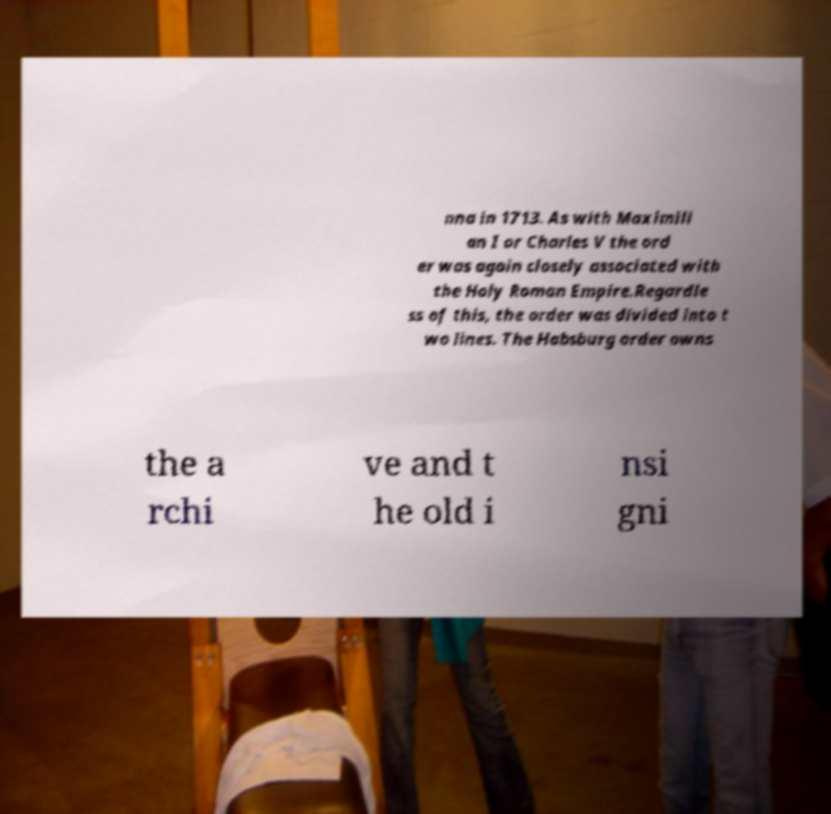Can you accurately transcribe the text from the provided image for me? nna in 1713. As with Maximili an I or Charles V the ord er was again closely associated with the Holy Roman Empire.Regardle ss of this, the order was divided into t wo lines. The Habsburg order owns the a rchi ve and t he old i nsi gni 